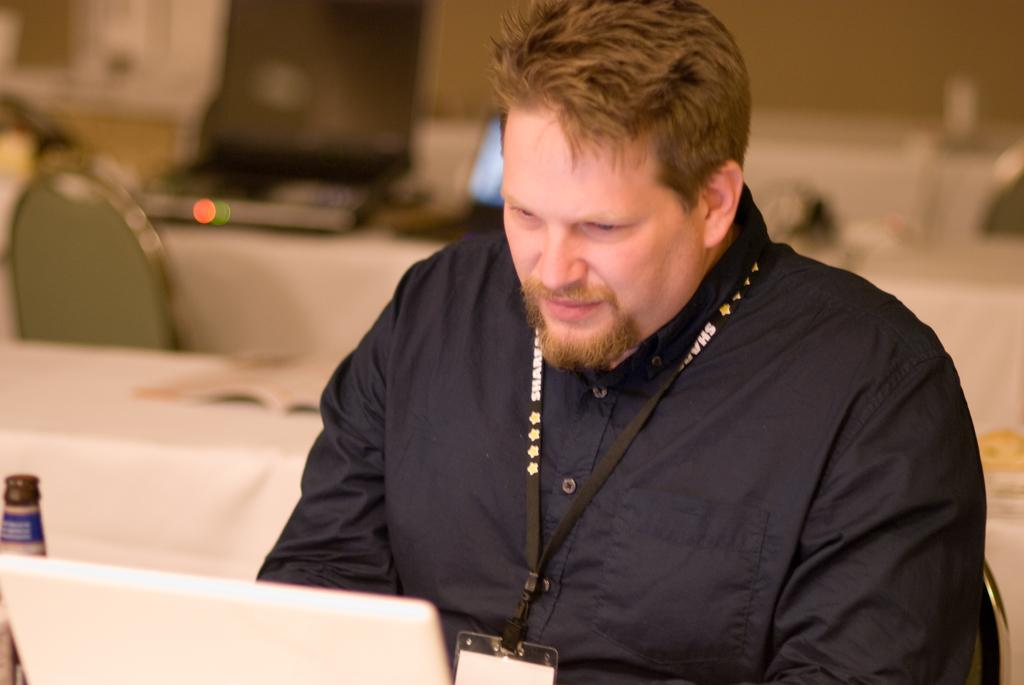What is the main subject of the image? The main subject of the image is a man. What is the man doing in the image? The man is seated on a chair in the image. What objects are in front of the man? There is a laptop and a bottle in front of the man. Can you describe the setting in the background? There are more tables and chairs visible in the background, along with additional laptops. What type of harbor can be seen in the image? There is no harbor present in the image. 